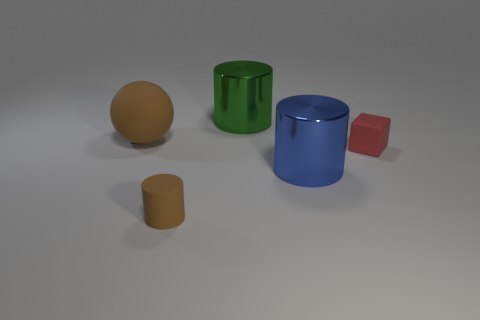Subtract 1 cylinders. How many cylinders are left? 2 Add 3 small brown rubber objects. How many objects exist? 8 Subtract all cylinders. How many objects are left? 2 Subtract all small rubber blocks. Subtract all yellow shiny cylinders. How many objects are left? 4 Add 3 big cylinders. How many big cylinders are left? 5 Add 2 small cyan matte blocks. How many small cyan matte blocks exist? 2 Subtract 1 green cylinders. How many objects are left? 4 